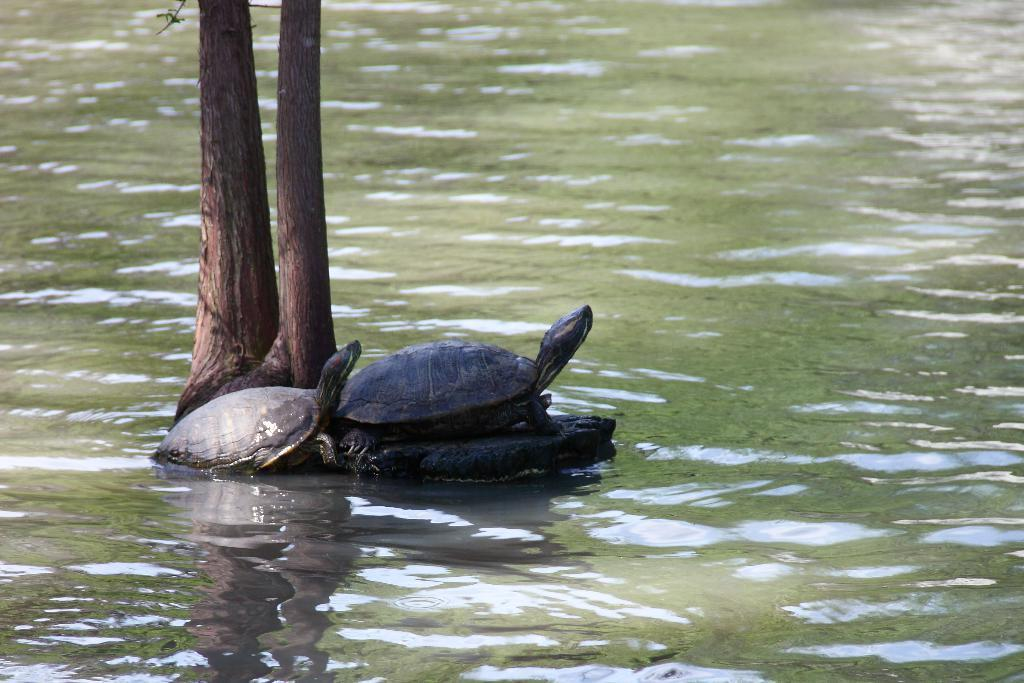How many tortoises are in the image? There are two tortoises in the image. Where are the tortoises located? The tortoises are on a rock. What type of vegetation can be seen in the image? There are trees visible in the image. What else can be seen in the image besides the tortoises and trees? There is water visible in the image. Can you tell me what the maid is doing in the image? There is no maid present in the image; it features two tortoises on a rock with trees and water visible in the background. 